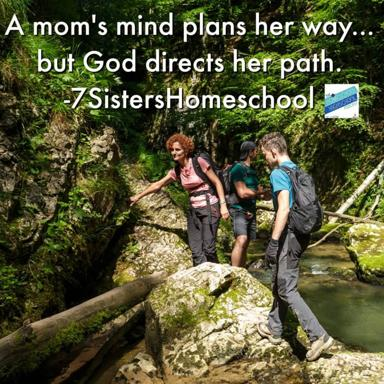Describe the clothing and gear the hikers are using. The hikers are outfitted in typical outdoor attire suitable for trekking through challenging terrains. They wear waterproof boots, comfortable clothing enabling ease of movement, and backpacks for carrying essentials. Such gear suggests they are prepared for various natural conditions, emphasizing readiness and adaptability. 